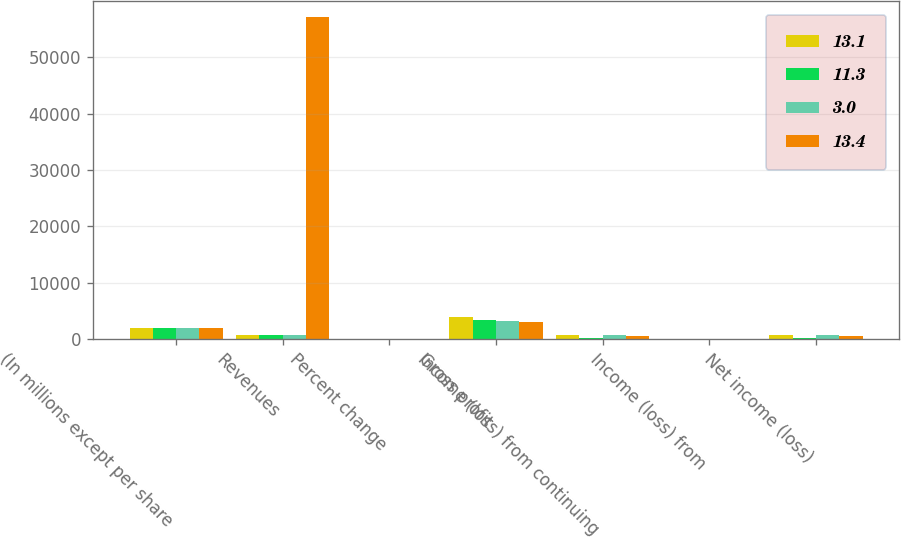Convert chart. <chart><loc_0><loc_0><loc_500><loc_500><stacked_bar_chart><ecel><fcel>(In millions except per share<fcel>Revenues<fcel>Percent change<fcel>Gross profit<fcel>Income (loss) from continuing<fcel>Income (loss) from<fcel>Net income (loss)<nl><fcel>13.1<fcel>2006<fcel>647<fcel>9.9<fcel>3862<fcel>737<fcel>14<fcel>751<nl><fcel>11.3<fcel>2005<fcel>647<fcel>15.8<fcel>3450<fcel>160<fcel>3<fcel>157<nl><fcel>3<fcel>2004<fcel>647<fcel>21.3<fcel>3235<fcel>643<fcel>4<fcel>647<nl><fcel>13.4<fcel>2003<fcel>57077<fcel>14.3<fcel>3092<fcel>559<fcel>4<fcel>555<nl></chart> 